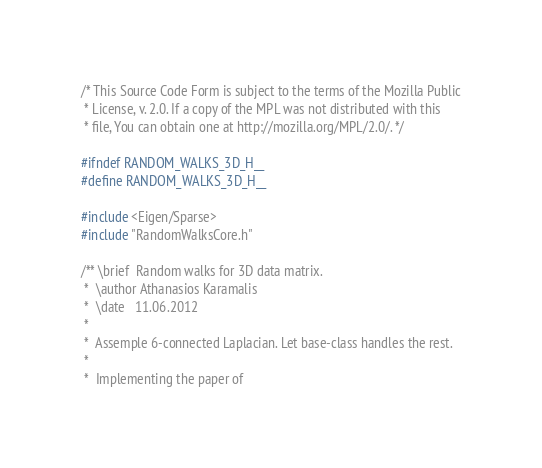<code> <loc_0><loc_0><loc_500><loc_500><_C_>/* This Source Code Form is subject to the terms of the Mozilla Public
 * License, v. 2.0. If a copy of the MPL was not distributed with this
 * file, You can obtain one at http://mozilla.org/MPL/2.0/. */

#ifndef RANDOM_WALKS_3D_H__
#define RANDOM_WALKS_3D_H__

#include <Eigen/Sparse>
#include "RandomWalksCore.h"

/** \brief	Random walks for 3D data matrix.
 *	\author	Athanasios Karamalis
 *  \date	11.06.2012
 *
 *	Assemple 6-connected Laplacian. Let base-class handles the rest.
 *
 *	Implementing the paper of</code> 